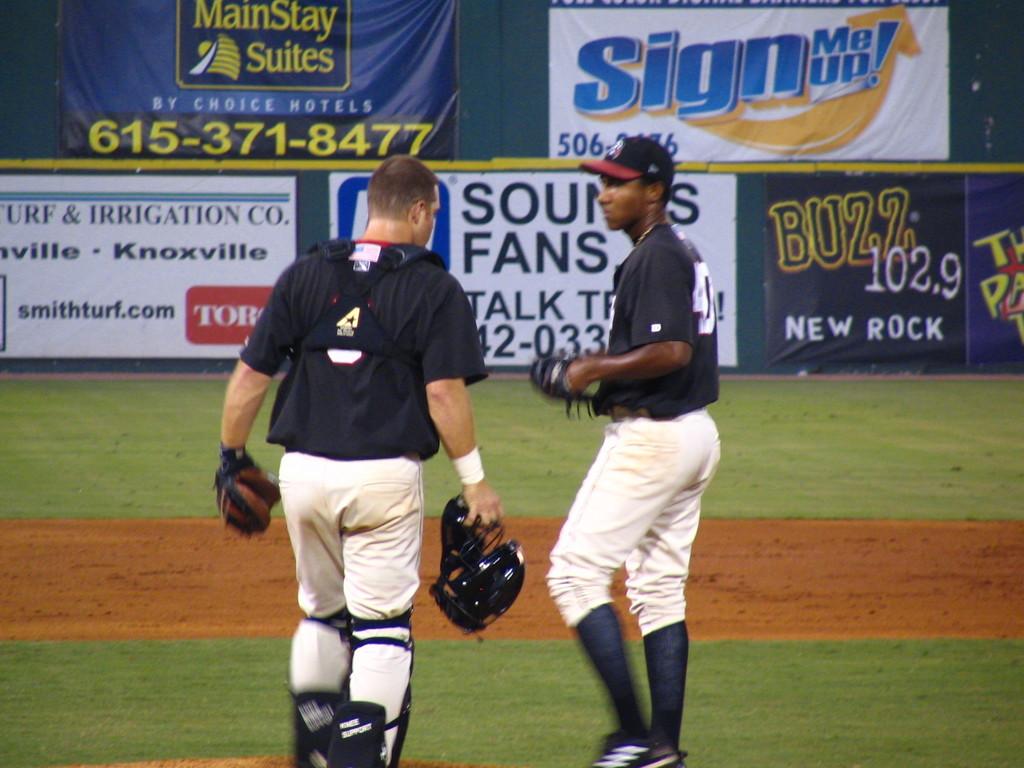What radio station who sponsors this game has, "new rock"?
Make the answer very short. Buzz 102.9. 